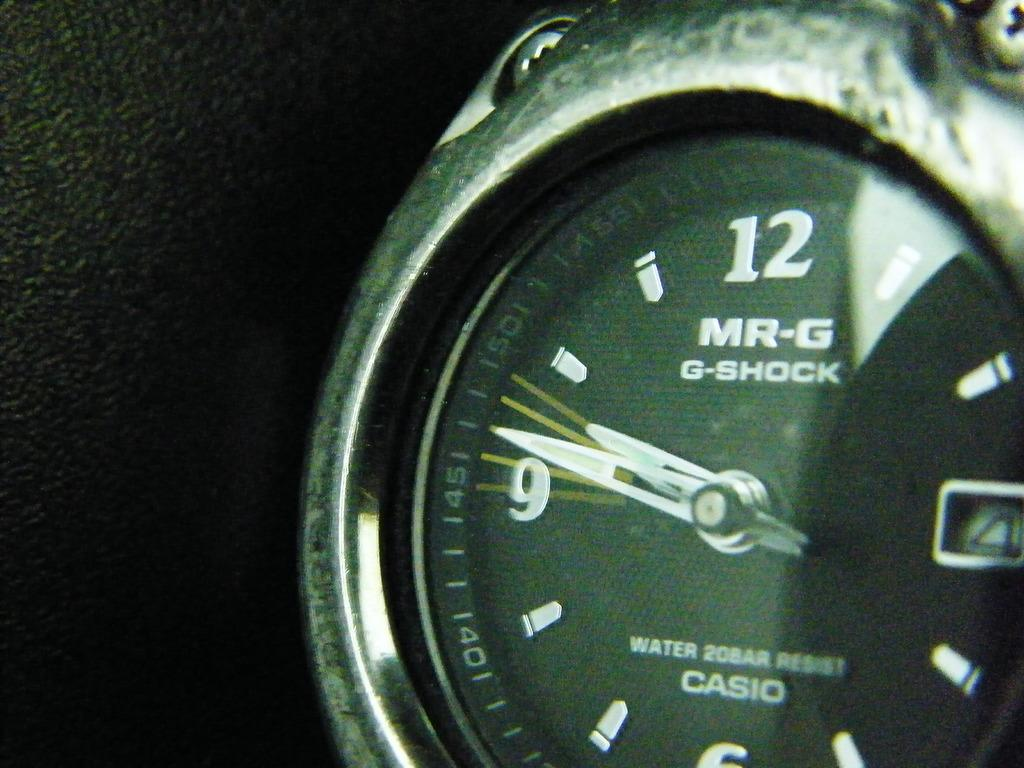<image>
Present a compact description of the photo's key features. Black face of a watch which says G-Shock in it. 